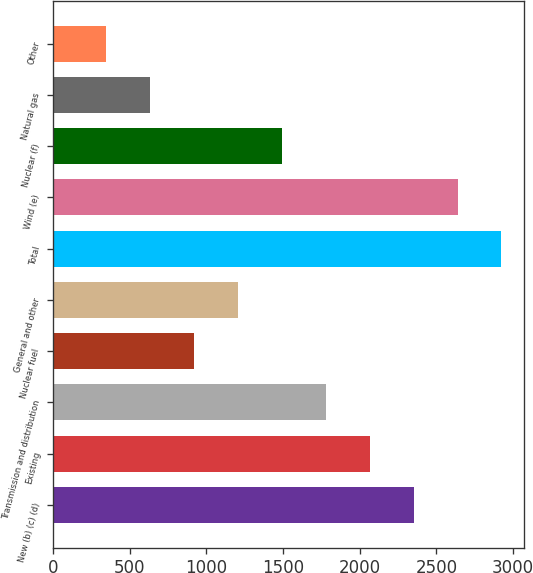Convert chart to OTSL. <chart><loc_0><loc_0><loc_500><loc_500><bar_chart><fcel>New (b) (c) (d)<fcel>Existing<fcel>Transmission and distribution<fcel>Nuclear fuel<fcel>General and other<fcel>Total<fcel>Wind (e)<fcel>Nuclear (f)<fcel>Natural gas<fcel>Other<nl><fcel>2352<fcel>2065.5<fcel>1779<fcel>919.5<fcel>1206<fcel>2925<fcel>2638.5<fcel>1492.5<fcel>633<fcel>346.5<nl></chart> 